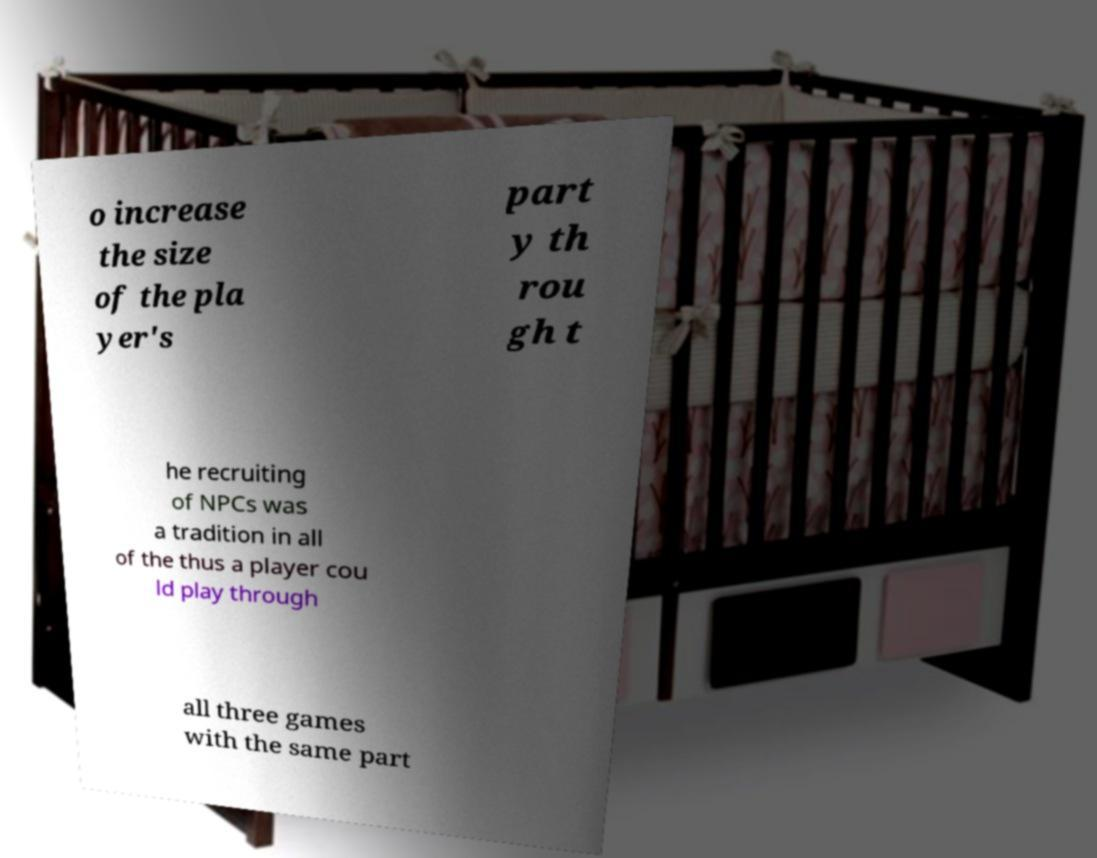Can you read and provide the text displayed in the image?This photo seems to have some interesting text. Can you extract and type it out for me? o increase the size of the pla yer's part y th rou gh t he recruiting of NPCs was a tradition in all of the thus a player cou ld play through all three games with the same part 